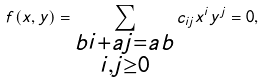<formula> <loc_0><loc_0><loc_500><loc_500>f ( x , y ) = \sum _ { \substack { b i + a j = a b \\ i , j \geq 0 } } c _ { i j } x ^ { i } y ^ { j } = 0 ,</formula> 